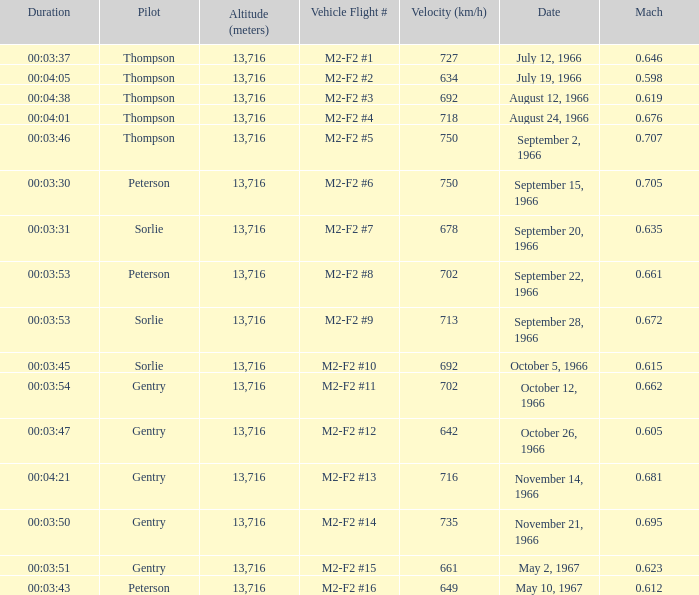What is the Mach with Vehicle Flight # m2-f2 #8 and an Altitude (meters) greater than 13,716? None. 